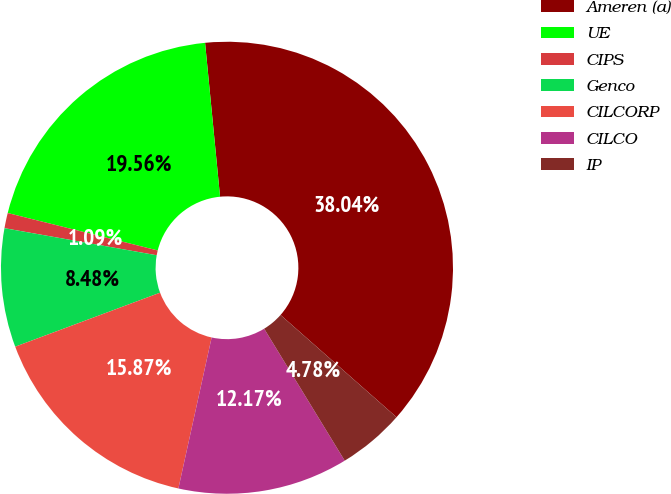Convert chart. <chart><loc_0><loc_0><loc_500><loc_500><pie_chart><fcel>Ameren (a)<fcel>UE<fcel>CIPS<fcel>Genco<fcel>CILCORP<fcel>CILCO<fcel>IP<nl><fcel>38.04%<fcel>19.56%<fcel>1.09%<fcel>8.48%<fcel>15.87%<fcel>12.17%<fcel>4.78%<nl></chart> 